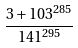Convert formula to latex. <formula><loc_0><loc_0><loc_500><loc_500>\frac { 3 + 1 0 3 ^ { 2 8 5 } } { 1 4 1 ^ { 2 9 5 } }</formula> 